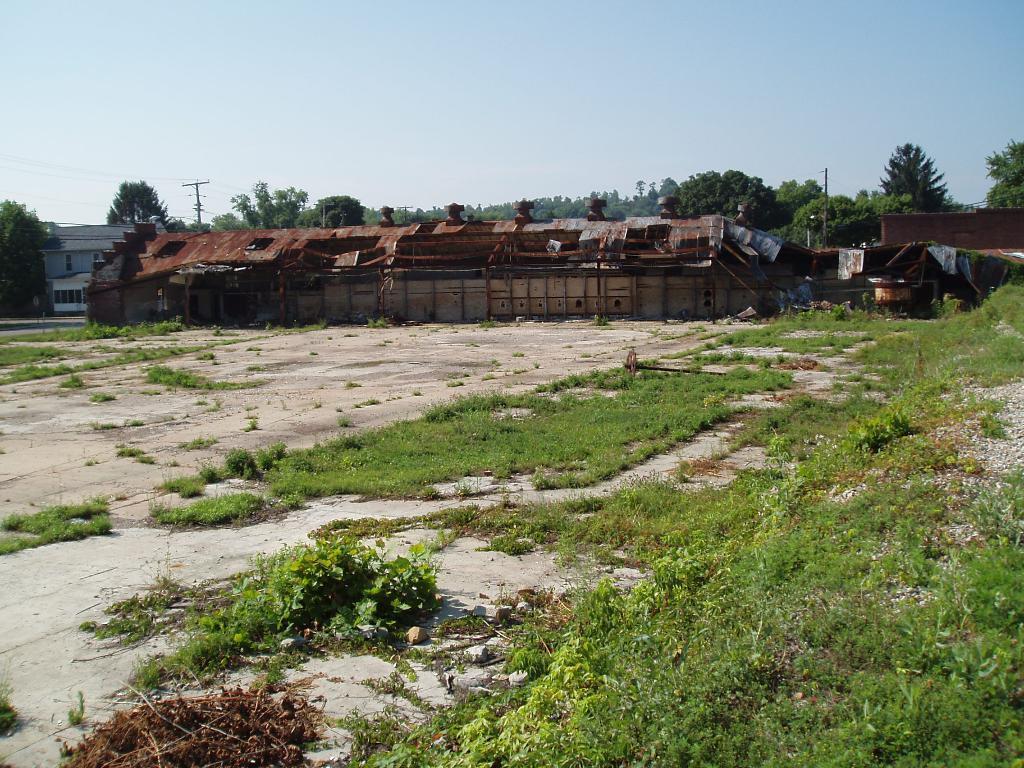How would you summarize this image in a sentence or two? In this picture we can see grass, plants, houses, poles, trees, other objects and the sky. 